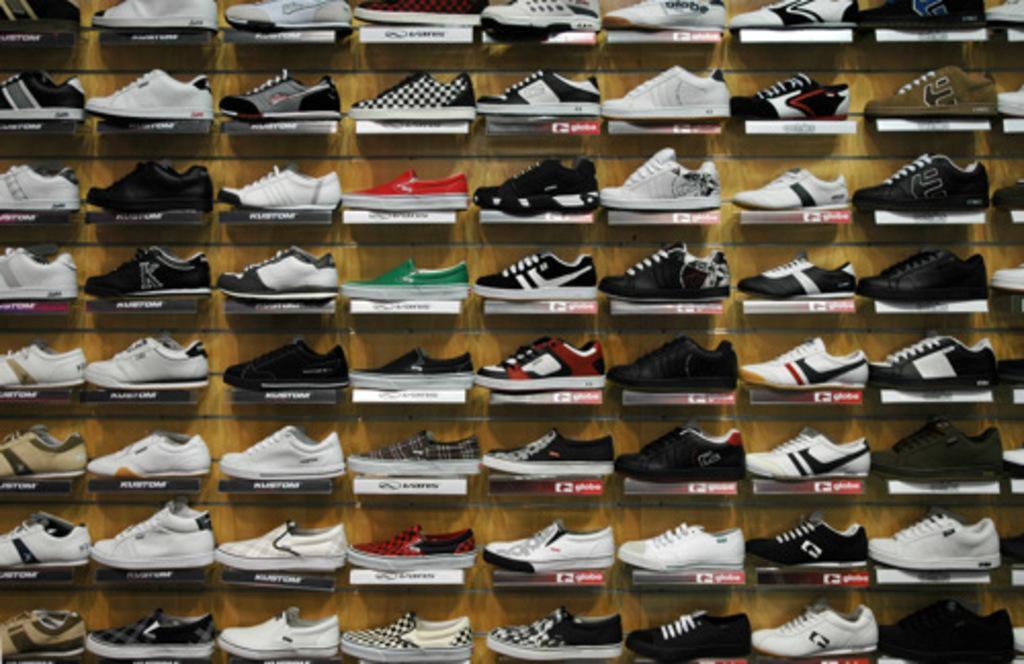How would you summarize this image in a sentence or two? In this image I can see number of shoes on these racks. I can also see something is written on every rack. 